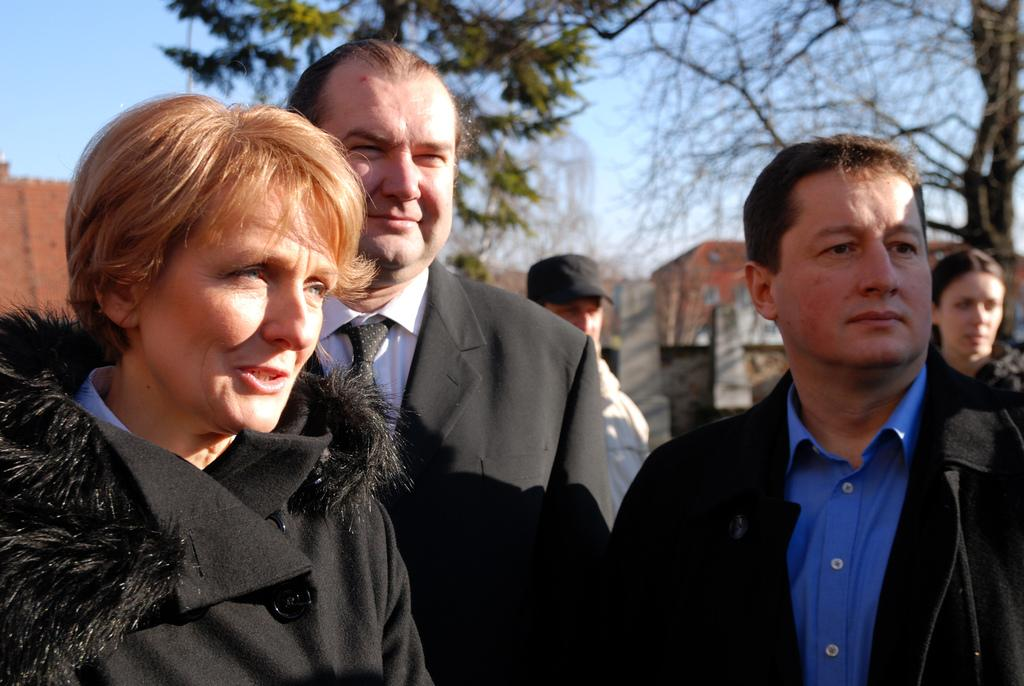What is happening in the image? There are people standing in the image. What can be seen in the background of the image? There are trees, buildings, and the sky visible in the background of the image. What type of needle is being used for learning in the image? There is no needle or learning activity present in the image. How many yams are visible in the image? There are no yams present in the image. 